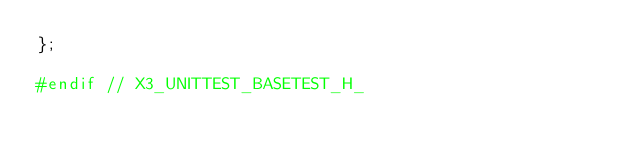<code> <loc_0><loc_0><loc_500><loc_500><_C_>};

#endif // X3_UNITTEST_BASETEST_H_
</code> 